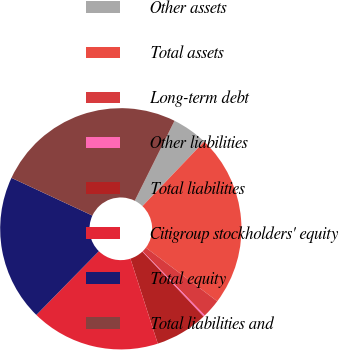Convert chart to OTSL. <chart><loc_0><loc_0><loc_500><loc_500><pie_chart><fcel>Other assets<fcel>Total assets<fcel>Long-term debt<fcel>Other liabilities<fcel>Total liabilities<fcel>Citigroup stockholders' equity<fcel>Total equity<fcel>Total liabilities and<nl><fcel>4.79%<fcel>23.11%<fcel>2.5%<fcel>0.21%<fcel>7.08%<fcel>17.3%<fcel>19.59%<fcel>25.4%<nl></chart> 